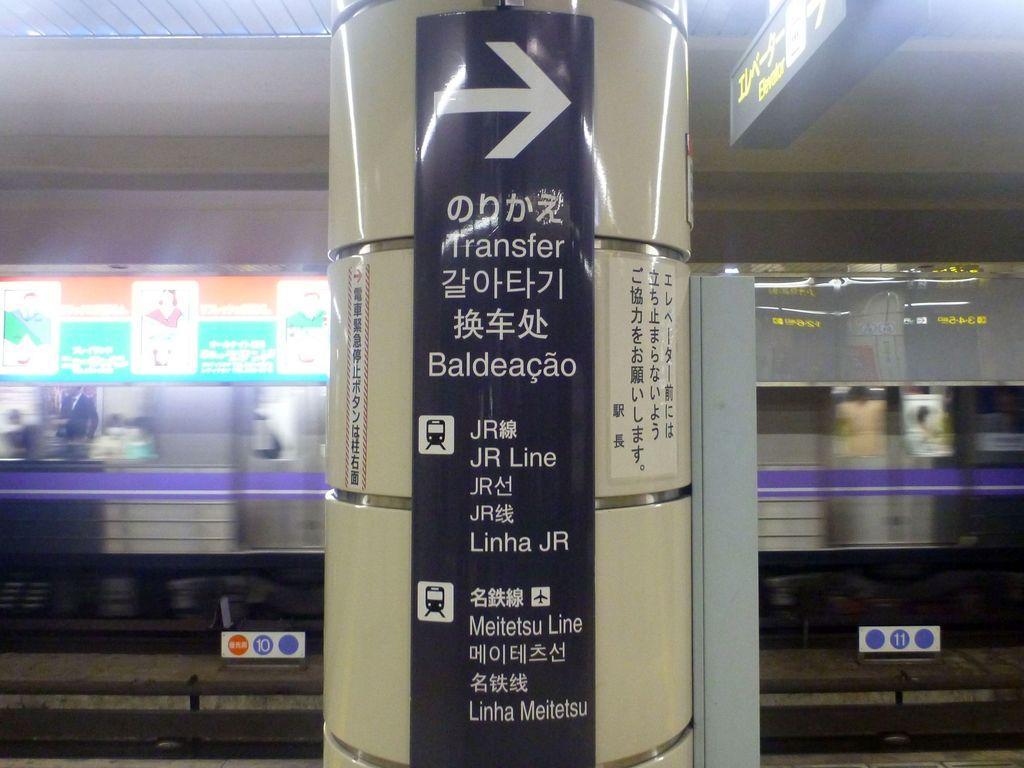<image>
Provide a brief description of the given image. A sign in a transit center in a foreign language directing people to Baldeacao. 